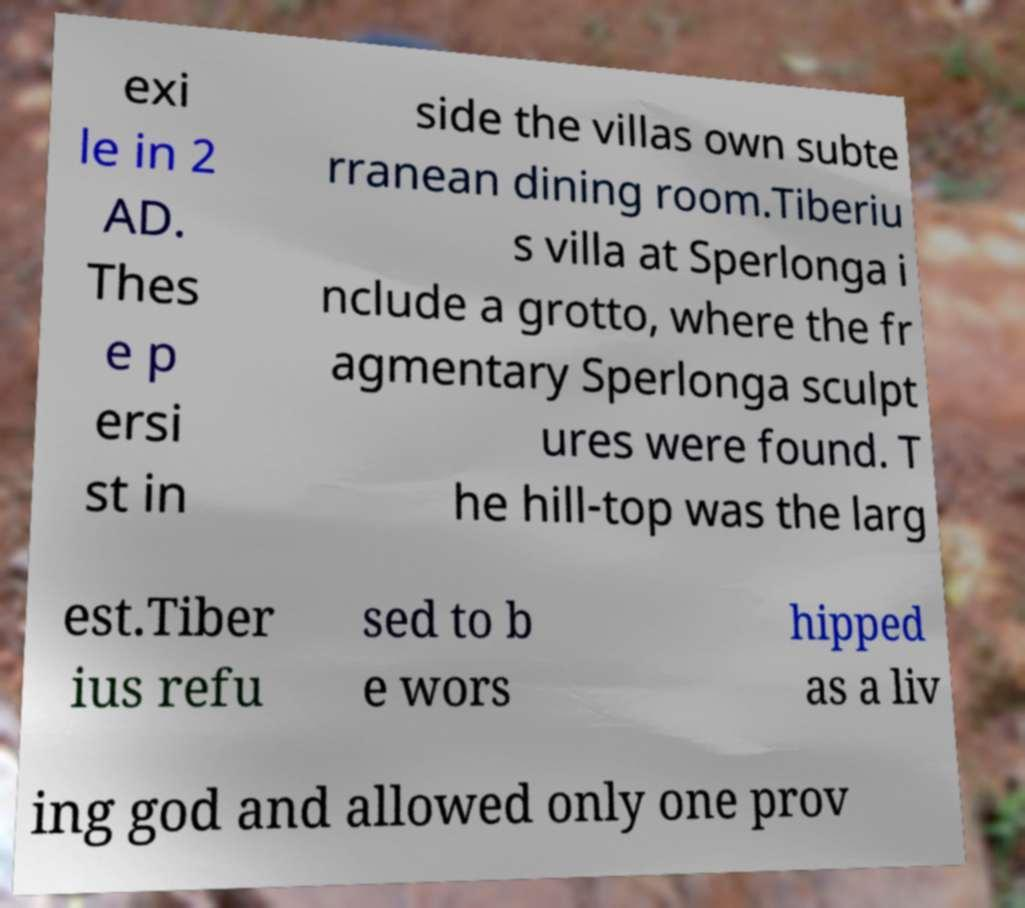Can you accurately transcribe the text from the provided image for me? exi le in 2 AD. Thes e p ersi st in side the villas own subte rranean dining room.Tiberiu s villa at Sperlonga i nclude a grotto, where the fr agmentary Sperlonga sculpt ures were found. T he hill-top was the larg est.Tiber ius refu sed to b e wors hipped as a liv ing god and allowed only one prov 